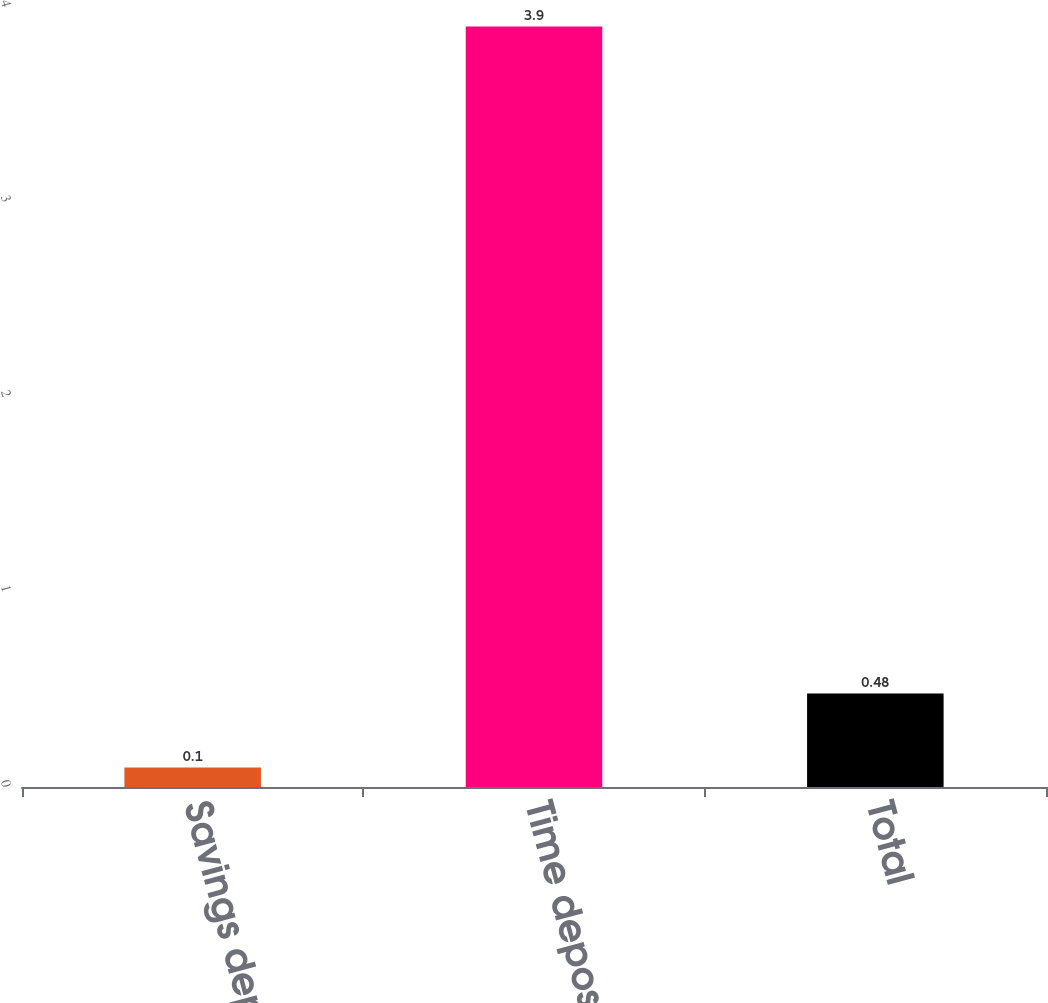<chart> <loc_0><loc_0><loc_500><loc_500><bar_chart><fcel>Savings deposits<fcel>Time deposits<fcel>Total<nl><fcel>0.1<fcel>3.9<fcel>0.48<nl></chart> 